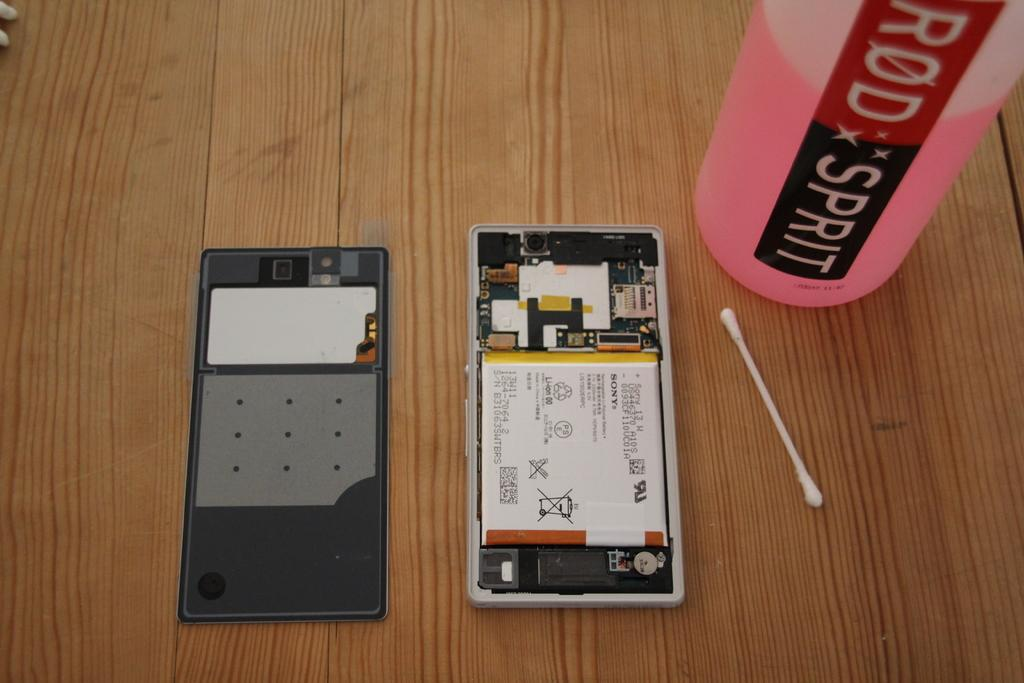<image>
Describe the image concisely. An open phone with the word SONY on its component label. 